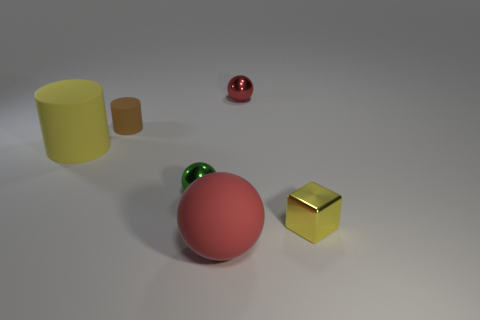Do the green object and the yellow cylinder have the same size?
Provide a short and direct response. No. How many other things are the same shape as the large yellow rubber thing?
Ensure brevity in your answer.  1. There is a yellow thing on the right side of the brown cylinder; what is its shape?
Provide a succinct answer. Cube. There is a small object that is right of the red shiny sphere; is its shape the same as the yellow thing left of the tiny cube?
Your response must be concise. No. Is the number of small green metallic balls that are behind the big rubber cylinder the same as the number of yellow things?
Keep it short and to the point. No. Is there anything else that is the same size as the red matte thing?
Provide a short and direct response. Yes. What is the material of the small brown object that is the same shape as the yellow matte thing?
Your answer should be very brief. Rubber. What shape is the red thing in front of the tiny metallic sphere to the right of the big red matte object?
Give a very brief answer. Sphere. Do the small object that is in front of the green metal object and the tiny green object have the same material?
Make the answer very short. Yes. Are there the same number of yellow shiny blocks behind the big yellow cylinder and tiny yellow things behind the brown cylinder?
Your response must be concise. Yes. 